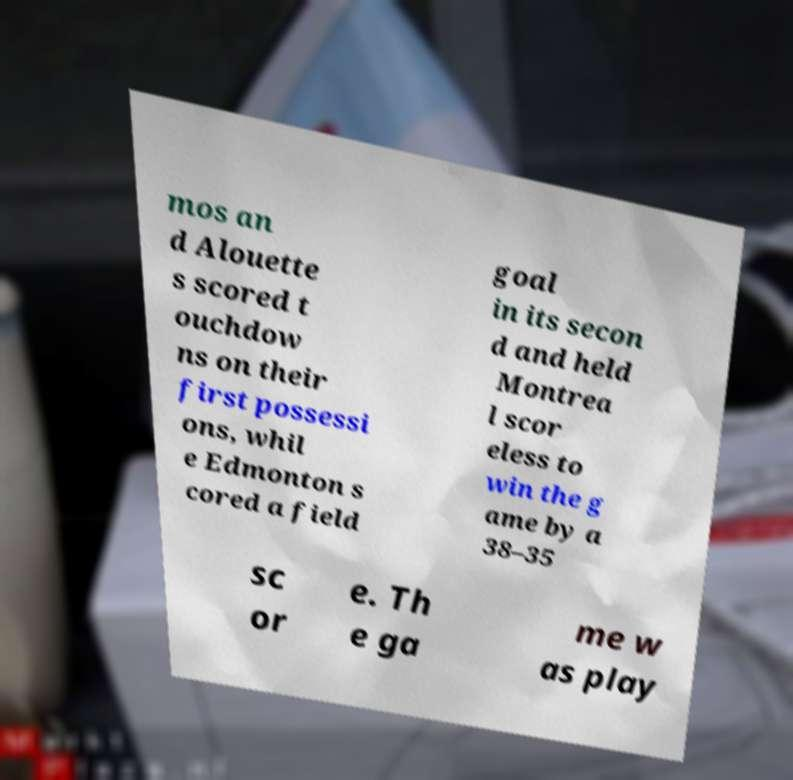For documentation purposes, I need the text within this image transcribed. Could you provide that? mos an d Alouette s scored t ouchdow ns on their first possessi ons, whil e Edmonton s cored a field goal in its secon d and held Montrea l scor eless to win the g ame by a 38–35 sc or e. Th e ga me w as play 